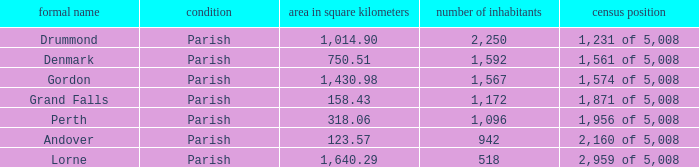What is the area of the parish with a population larger than 1,172 and a census ranking of 1,871 of 5,008? 0.0. 